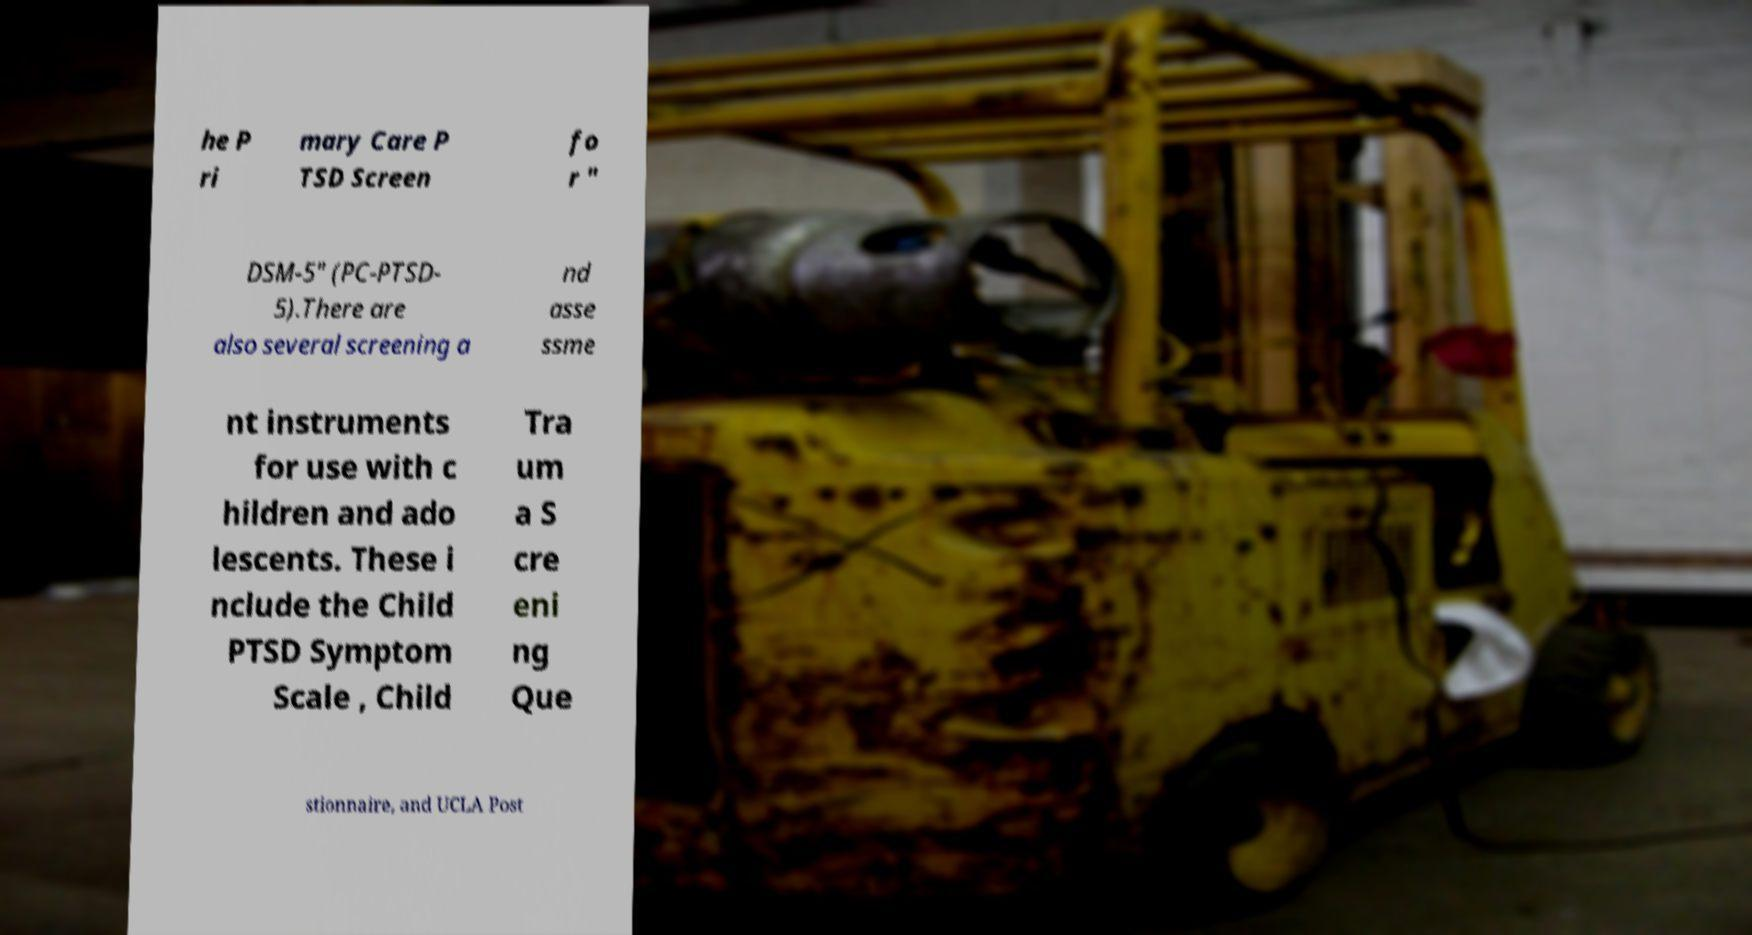Please identify and transcribe the text found in this image. he P ri mary Care P TSD Screen fo r " DSM-5" (PC-PTSD- 5).There are also several screening a nd asse ssme nt instruments for use with c hildren and ado lescents. These i nclude the Child PTSD Symptom Scale , Child Tra um a S cre eni ng Que stionnaire, and UCLA Post 